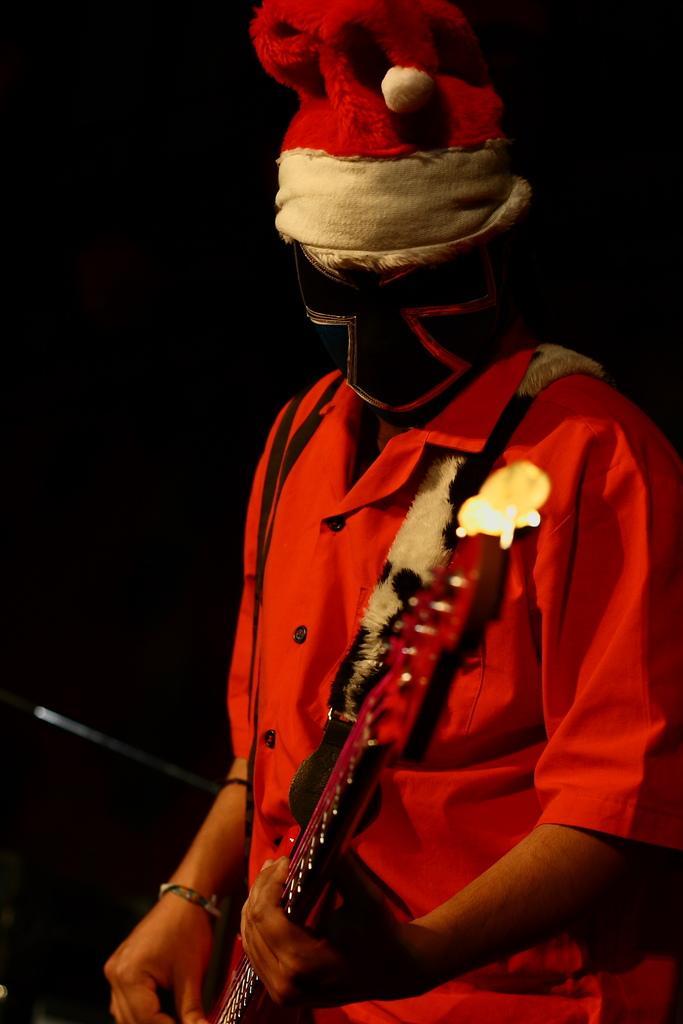Could you give a brief overview of what you see in this image? In this picture we can see a man, he wore a mask and a red color shirt, and he is holding a guitar. 